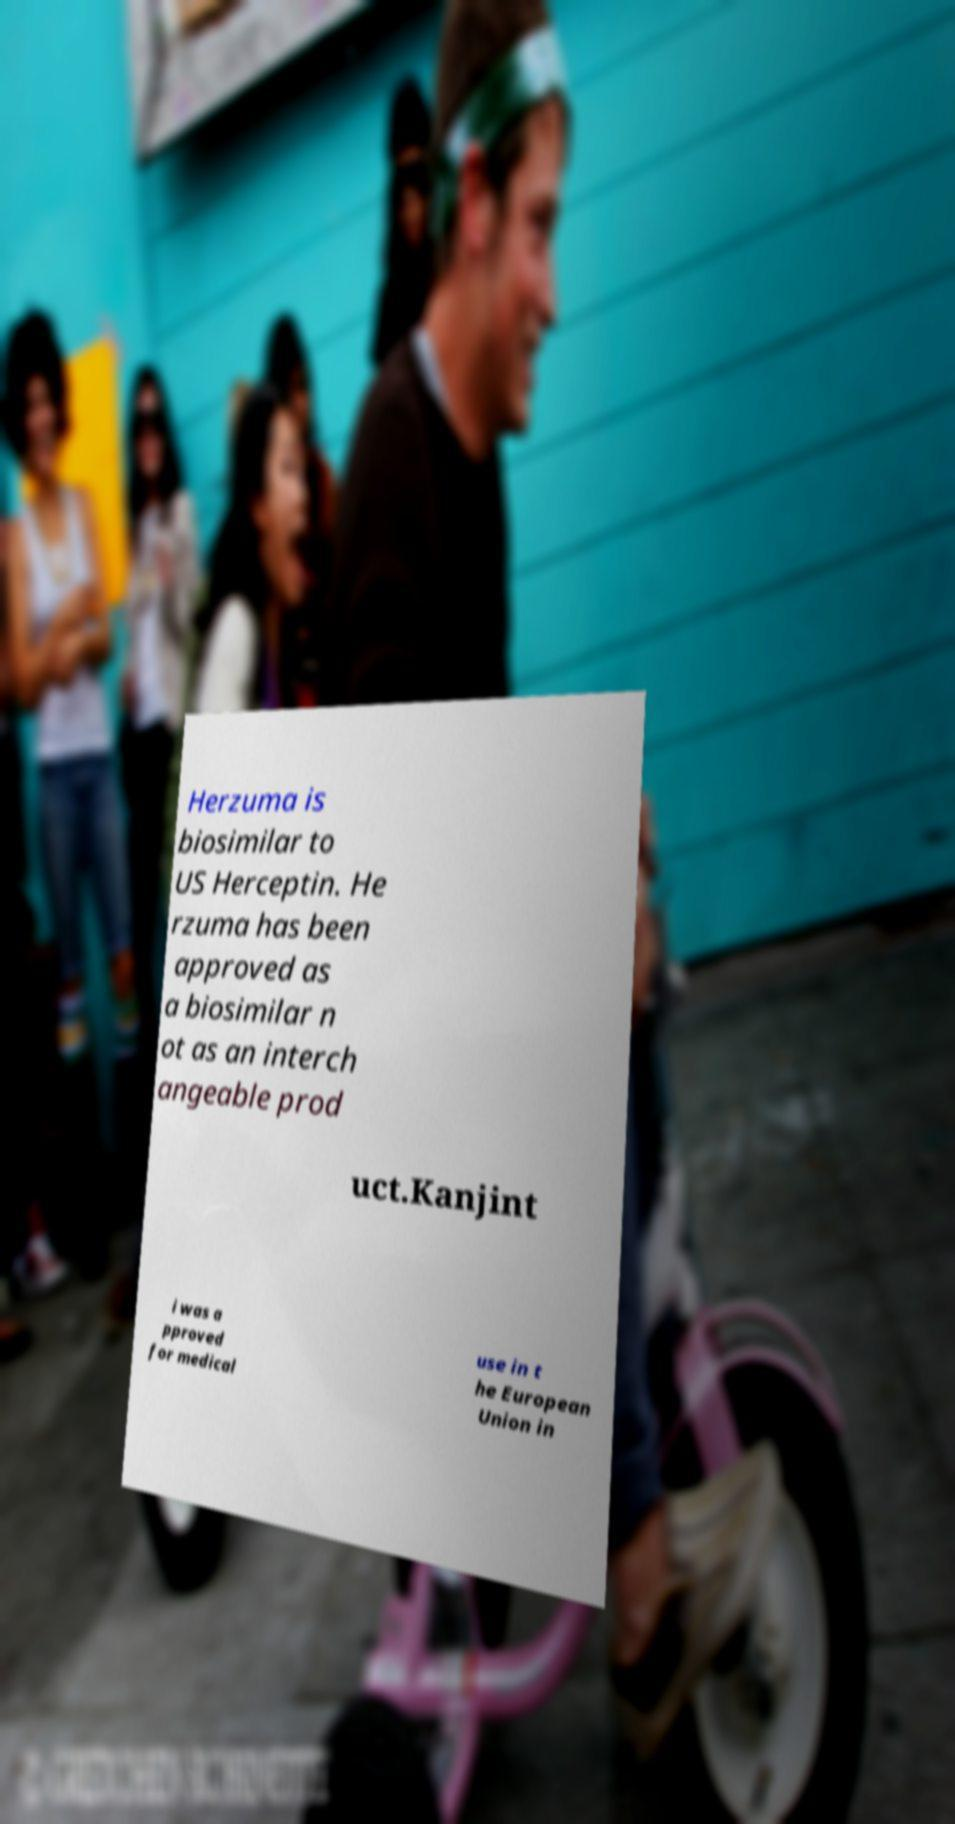What messages or text are displayed in this image? I need them in a readable, typed format. Herzuma is biosimilar to US Herceptin. He rzuma has been approved as a biosimilar n ot as an interch angeable prod uct.Kanjint i was a pproved for medical use in t he European Union in 